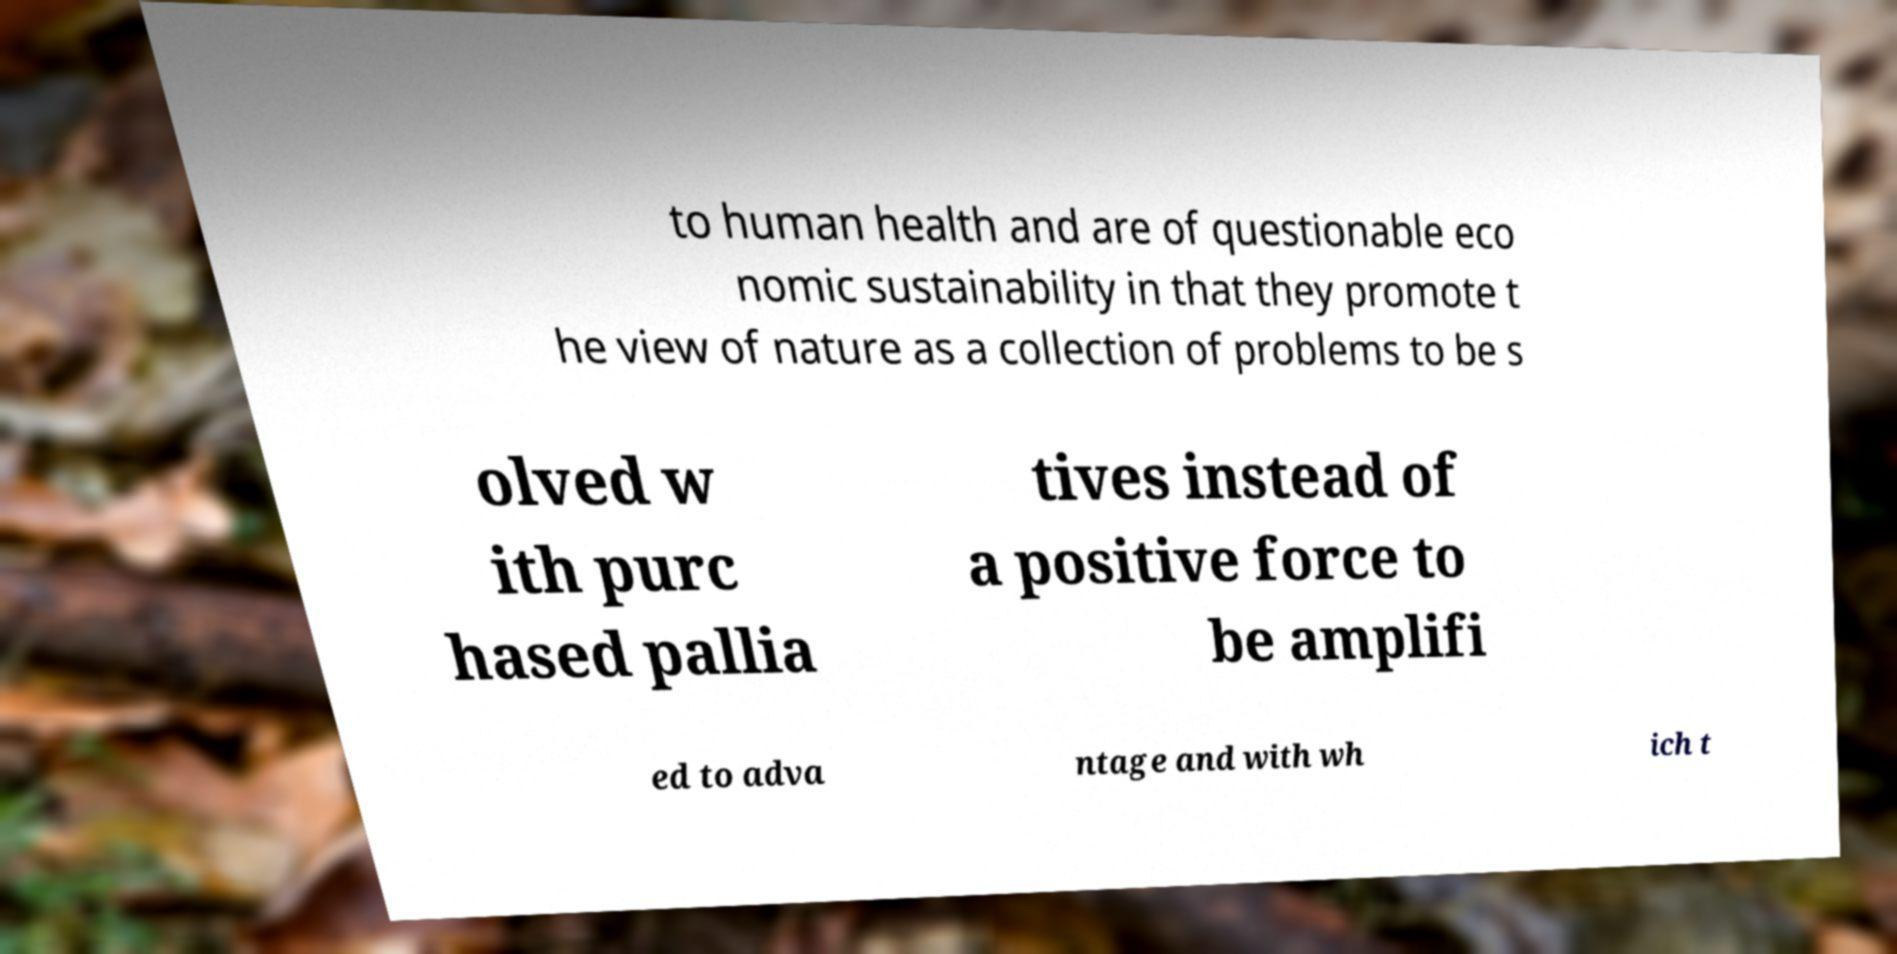Could you extract and type out the text from this image? to human health and are of questionable eco nomic sustainability in that they promote t he view of nature as a collection of problems to be s olved w ith purc hased pallia tives instead of a positive force to be amplifi ed to adva ntage and with wh ich t 